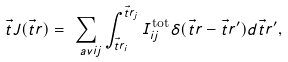Convert formula to latex. <formula><loc_0><loc_0><loc_500><loc_500>\vec { t } { J } ( \vec { t } { r } ) = \sum _ { \ a v { i j } } \int _ { \vec { t } { r } _ { i } } ^ { \vec { t } { r } _ { j } } I ^ { \text {tot} } _ { i j } \delta ( \vec { t } { r } - \vec { t } { r ^ { \prime } } ) d \vec { t } { r ^ { \prime } } ,</formula> 